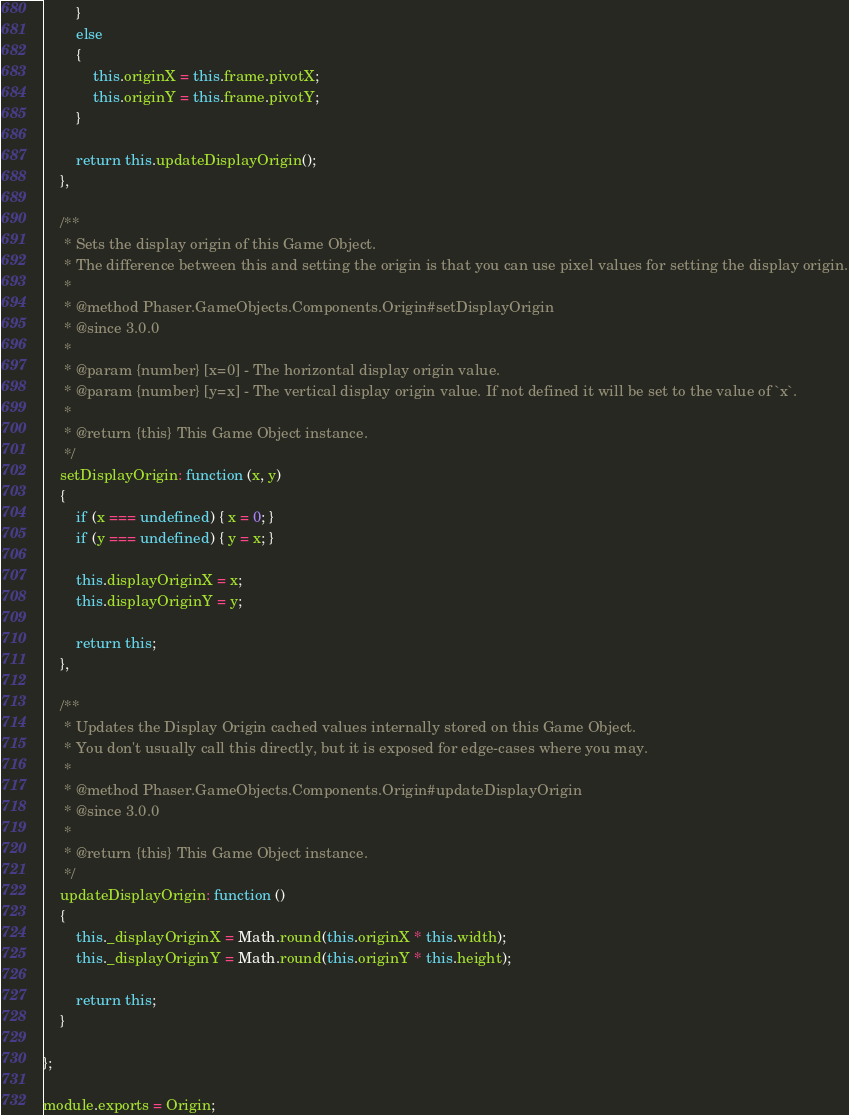Convert code to text. <code><loc_0><loc_0><loc_500><loc_500><_JavaScript_>        }
        else
        {
            this.originX = this.frame.pivotX;
            this.originY = this.frame.pivotY;
        }

        return this.updateDisplayOrigin();
    },

    /**
     * Sets the display origin of this Game Object.
     * The difference between this and setting the origin is that you can use pixel values for setting the display origin.
     *
     * @method Phaser.GameObjects.Components.Origin#setDisplayOrigin
     * @since 3.0.0
     *
     * @param {number} [x=0] - The horizontal display origin value.
     * @param {number} [y=x] - The vertical display origin value. If not defined it will be set to the value of `x`.
     *
     * @return {this} This Game Object instance.
     */
    setDisplayOrigin: function (x, y)
    {
        if (x === undefined) { x = 0; }
        if (y === undefined) { y = x; }

        this.displayOriginX = x;
        this.displayOriginY = y;

        return this;
    },

    /**
     * Updates the Display Origin cached values internally stored on this Game Object.
     * You don't usually call this directly, but it is exposed for edge-cases where you may.
     *
     * @method Phaser.GameObjects.Components.Origin#updateDisplayOrigin
     * @since 3.0.0
     *
     * @return {this} This Game Object instance.
     */
    updateDisplayOrigin: function ()
    {
        this._displayOriginX = Math.round(this.originX * this.width);
        this._displayOriginY = Math.round(this.originY * this.height);

        return this;
    }

};

module.exports = Origin;
</code> 